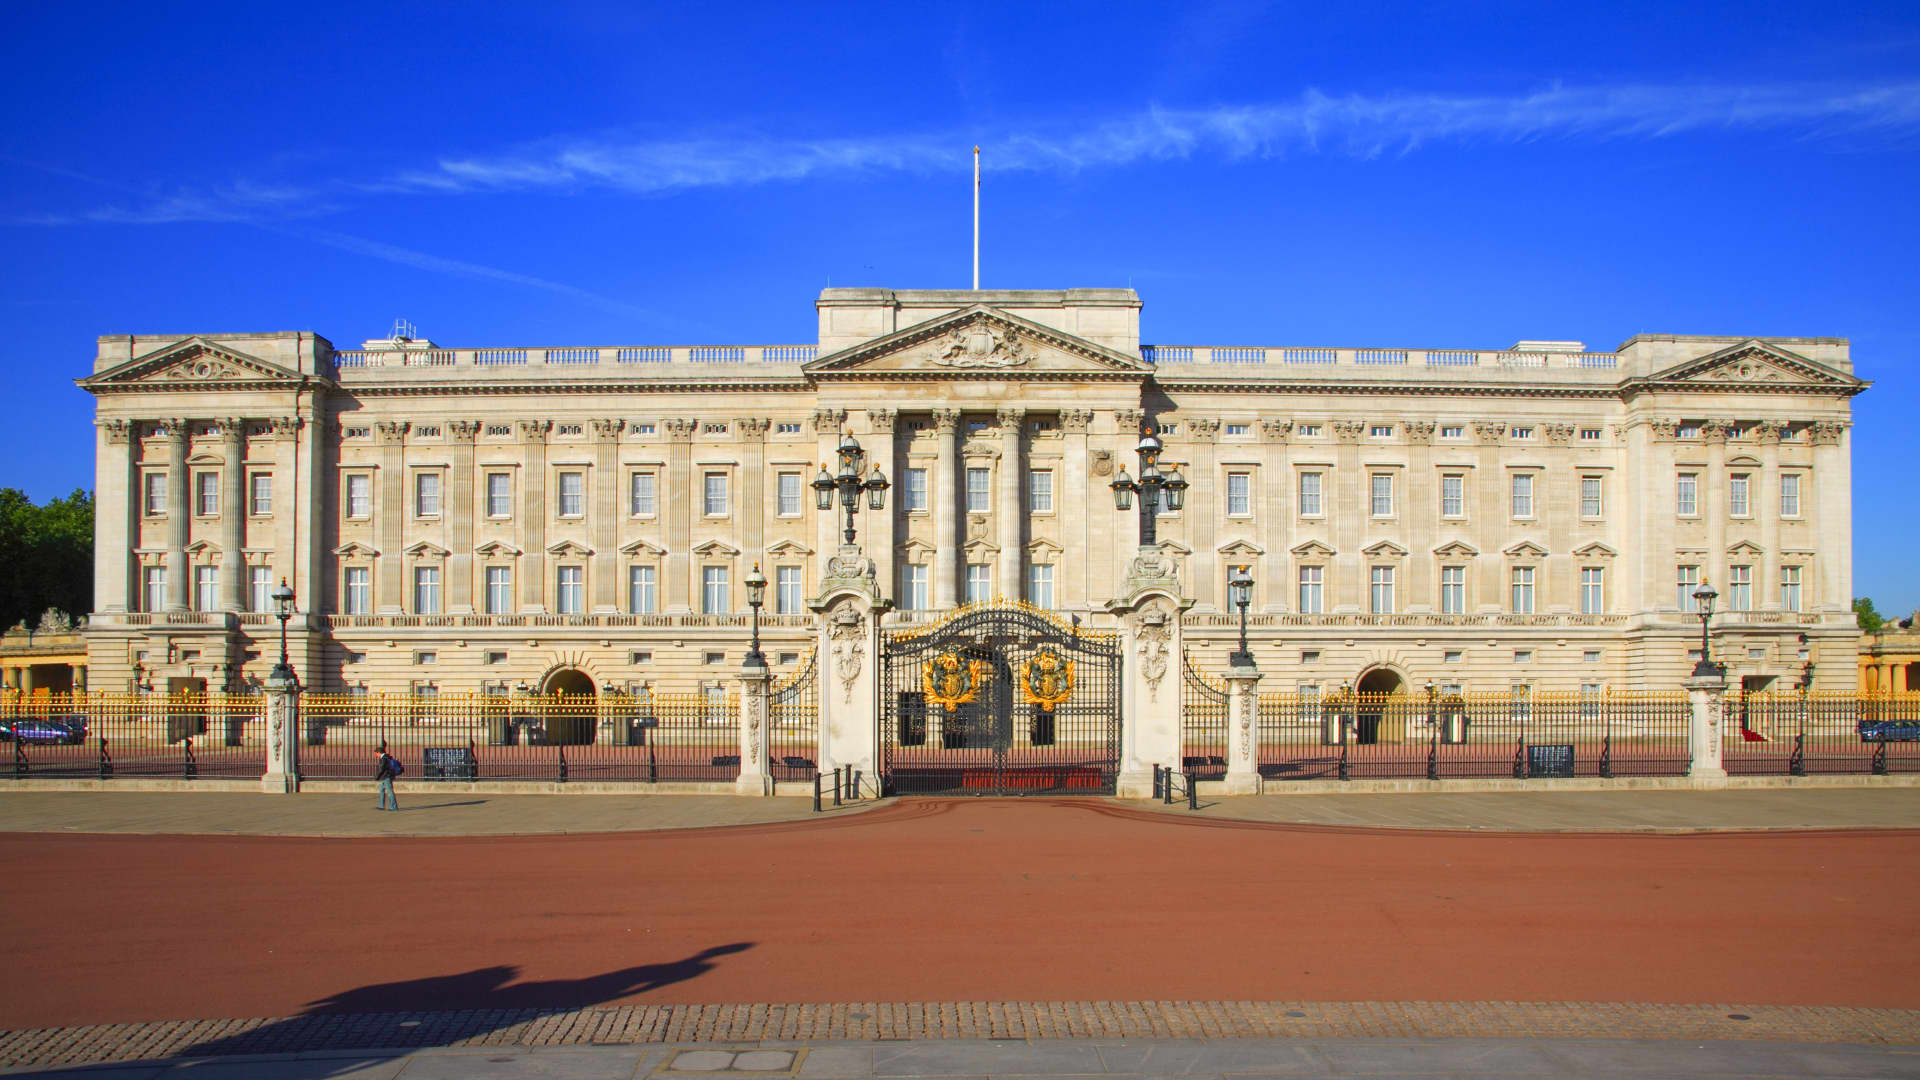Describe a typical day at Buckingham Palace. A typical day at Buckingham Palace begins early in the morning when the palace staff commence their duties to prepare for the day's events. The Changing of the Guard ceremony, a traditional and much-loved spectacle, takes place late in the morning, drawing crowds of spectators. Throughout the day, the palace's state rooms may host various official engagements, such as diplomatic meetings, receptions, and ceremonies. The Queen, if in residence, may conduct audiences with ministers or ambassadors. The vast kitchens are busy preparing meals for the staff and any official functions occurring later in the day. In the evening, the palace lights up, creating a serene yet majestic ambiance, as the household winds down and prepares for the next day of royal responsibilities and celebrations.  What makes the facade of Buckingham Palace iconic? The facade of Buckingham Palace is iconic due to its neoclassical architectural style and grand proportions. The symmetrical design, with its central balcony famously used for royal appearances, is both stately and elegant. The use of Portland stone gives the facade a distinctive, regal appearance that glows in sunlight. Additionally, the ornate iron gates, adorned with gold accents and the royal coat of arms, further enhance its majestic presence. The facade’s overall design reflects the monarchy’s dignity, history, and cultural significance, making it instantly recognizable worldwide. 